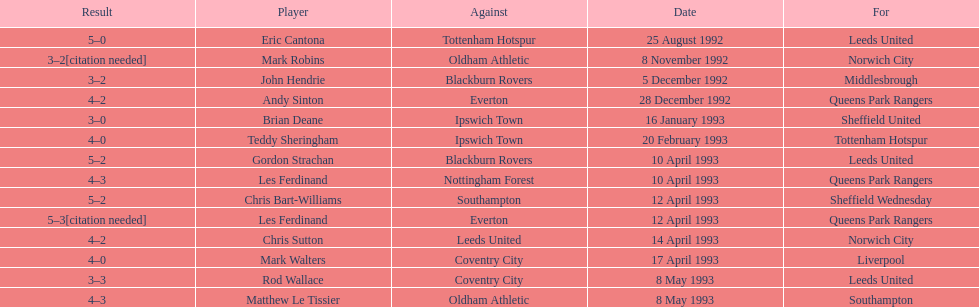Which player had the same result as mark robins? John Hendrie. 